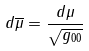Convert formula to latex. <formula><loc_0><loc_0><loc_500><loc_500>d \overline { \mu } = \frac { d \mu } { \sqrt { g _ { 0 0 } } }</formula> 